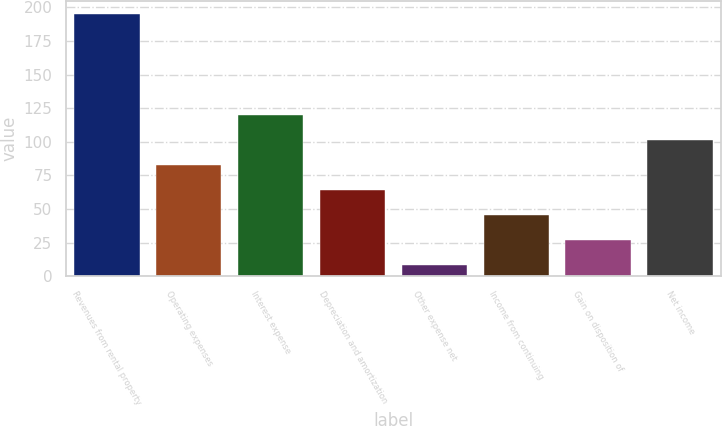<chart> <loc_0><loc_0><loc_500><loc_500><bar_chart><fcel>Revenues from rental property<fcel>Operating expenses<fcel>Interest expense<fcel>Depreciation and amortization<fcel>Other expense net<fcel>Income from continuing<fcel>Gain on disposition of<fcel>Net income<nl><fcel>195<fcel>82.98<fcel>120.32<fcel>64.31<fcel>8.3<fcel>45.64<fcel>26.97<fcel>101.65<nl></chart> 